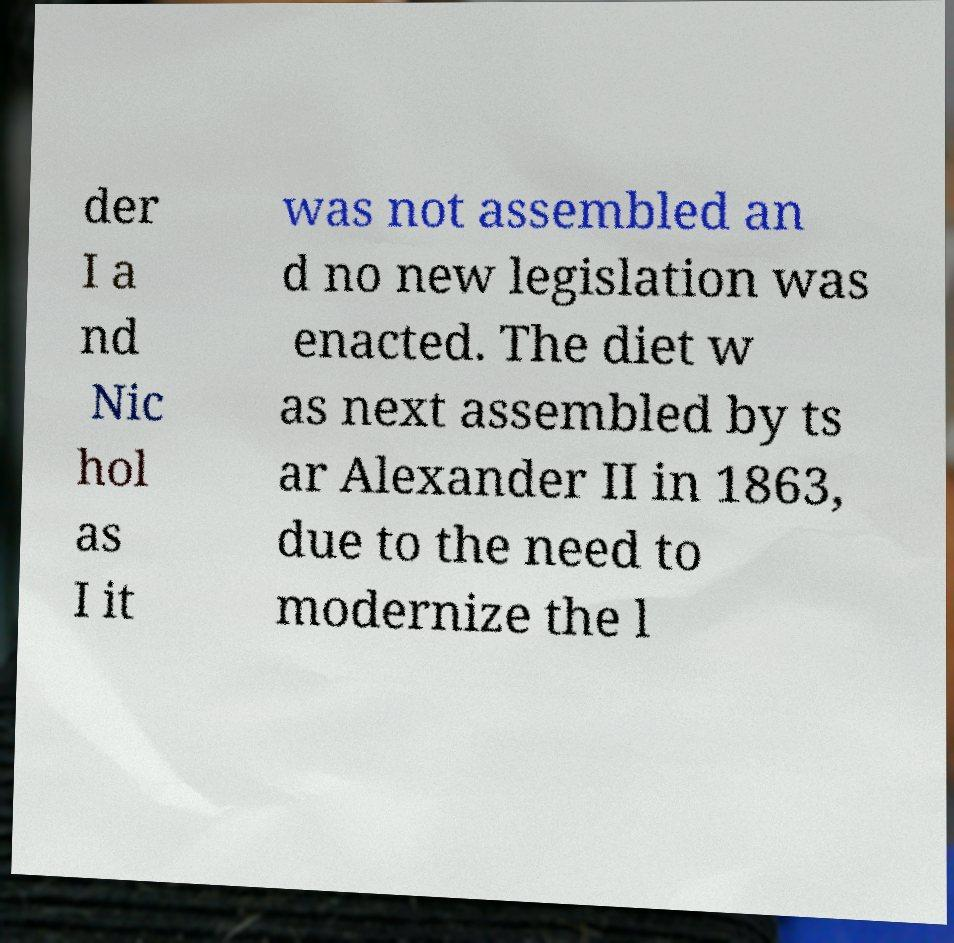Please read and relay the text visible in this image. What does it say? der I a nd Nic hol as I it was not assembled an d no new legislation was enacted. The diet w as next assembled by ts ar Alexander II in 1863, due to the need to modernize the l 